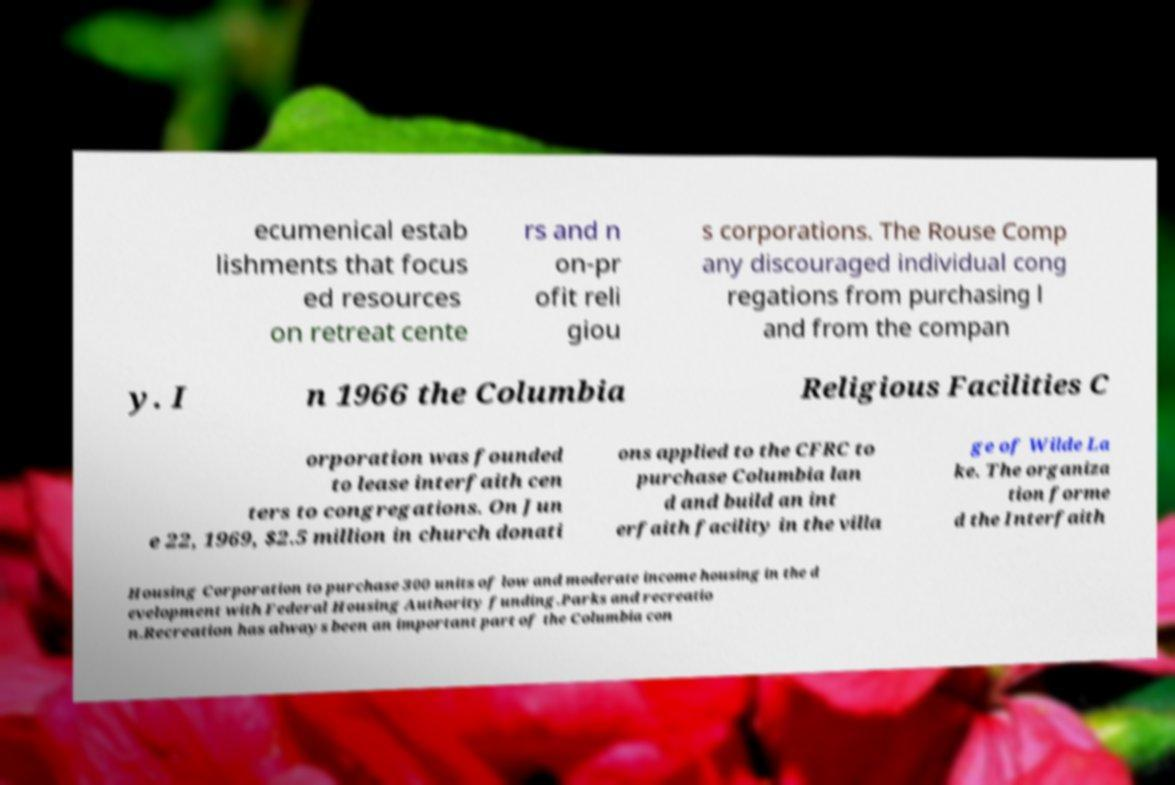Can you read and provide the text displayed in the image?This photo seems to have some interesting text. Can you extract and type it out for me? ecumenical estab lishments that focus ed resources on retreat cente rs and n on-pr ofit reli giou s corporations. The Rouse Comp any discouraged individual cong regations from purchasing l and from the compan y. I n 1966 the Columbia Religious Facilities C orporation was founded to lease interfaith cen ters to congregations. On Jun e 22, 1969, $2.5 million in church donati ons applied to the CFRC to purchase Columbia lan d and build an int erfaith facility in the villa ge of Wilde La ke. The organiza tion forme d the Interfaith Housing Corporation to purchase 300 units of low and moderate income housing in the d evelopment with Federal Housing Authority funding.Parks and recreatio n.Recreation has always been an important part of the Columbia con 